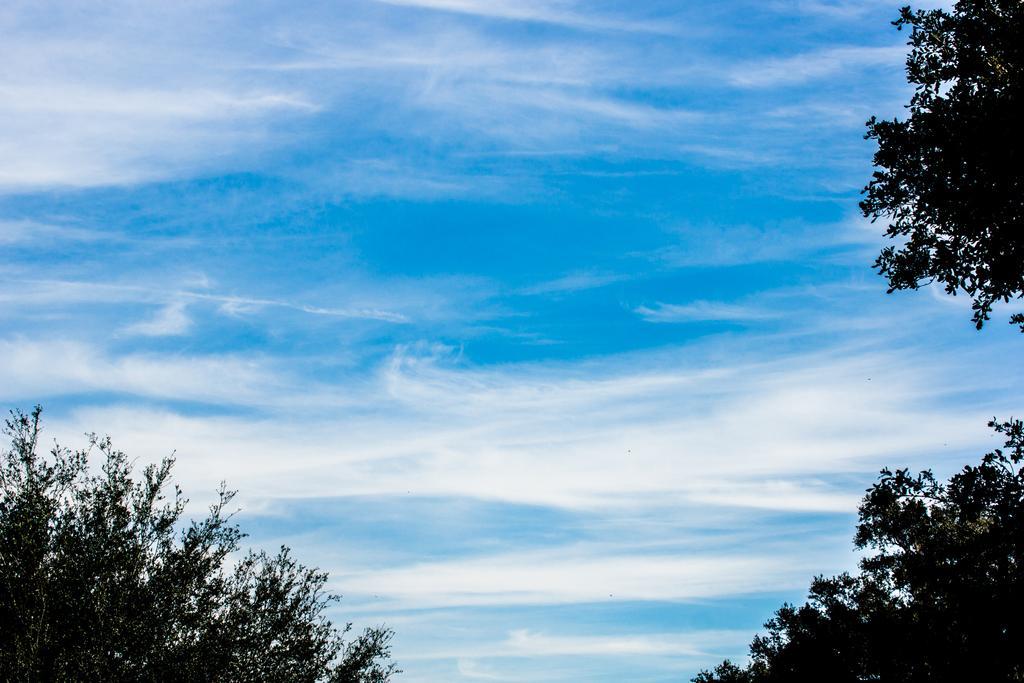Please provide a concise description of this image. In the image there are trees on either side and above its sky with clouds. 